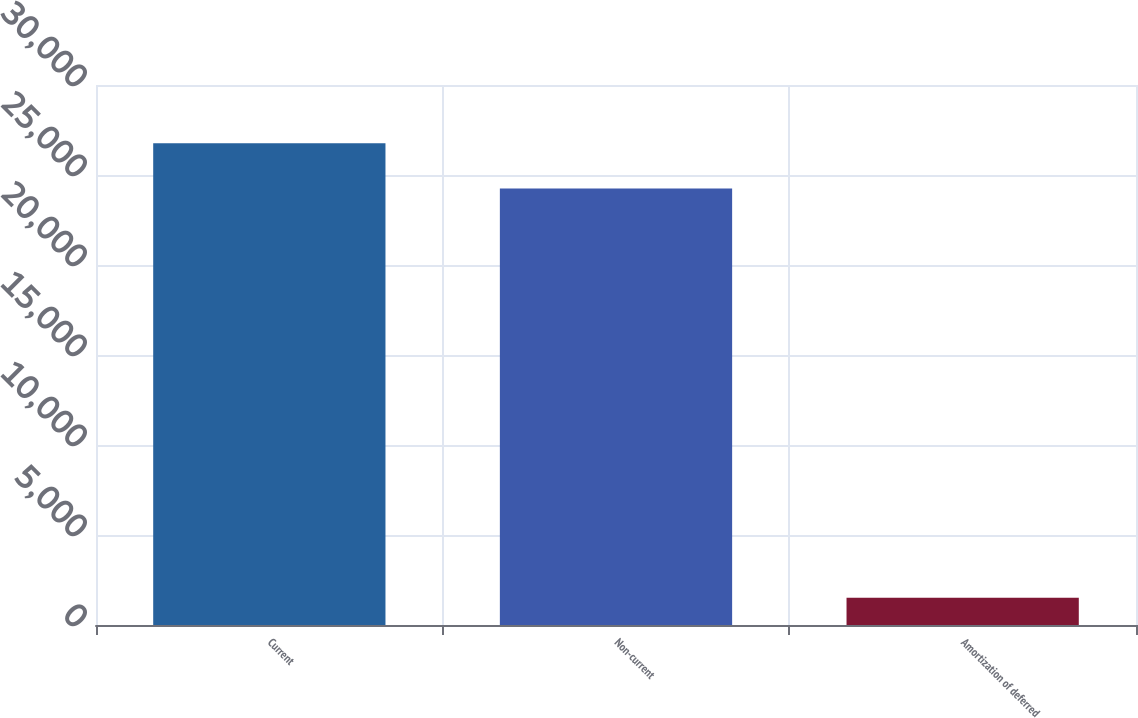Convert chart to OTSL. <chart><loc_0><loc_0><loc_500><loc_500><bar_chart><fcel>Current<fcel>Non-current<fcel>Amortization of deferred<nl><fcel>26764.6<fcel>24256<fcel>1518<nl></chart> 